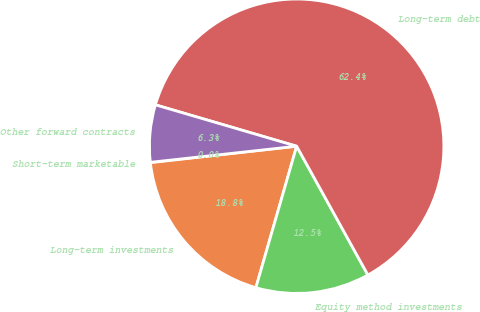Convert chart. <chart><loc_0><loc_0><loc_500><loc_500><pie_chart><fcel>Short-term marketable<fcel>Long-term investments<fcel>Equity method investments<fcel>Long-term debt<fcel>Other forward contracts<nl><fcel>0.04%<fcel>18.75%<fcel>12.51%<fcel>62.42%<fcel>6.28%<nl></chart> 